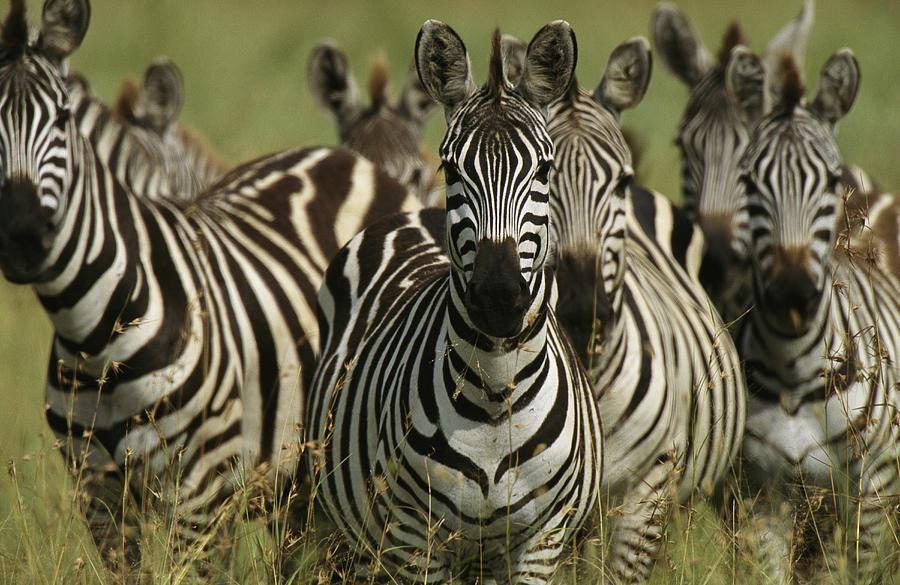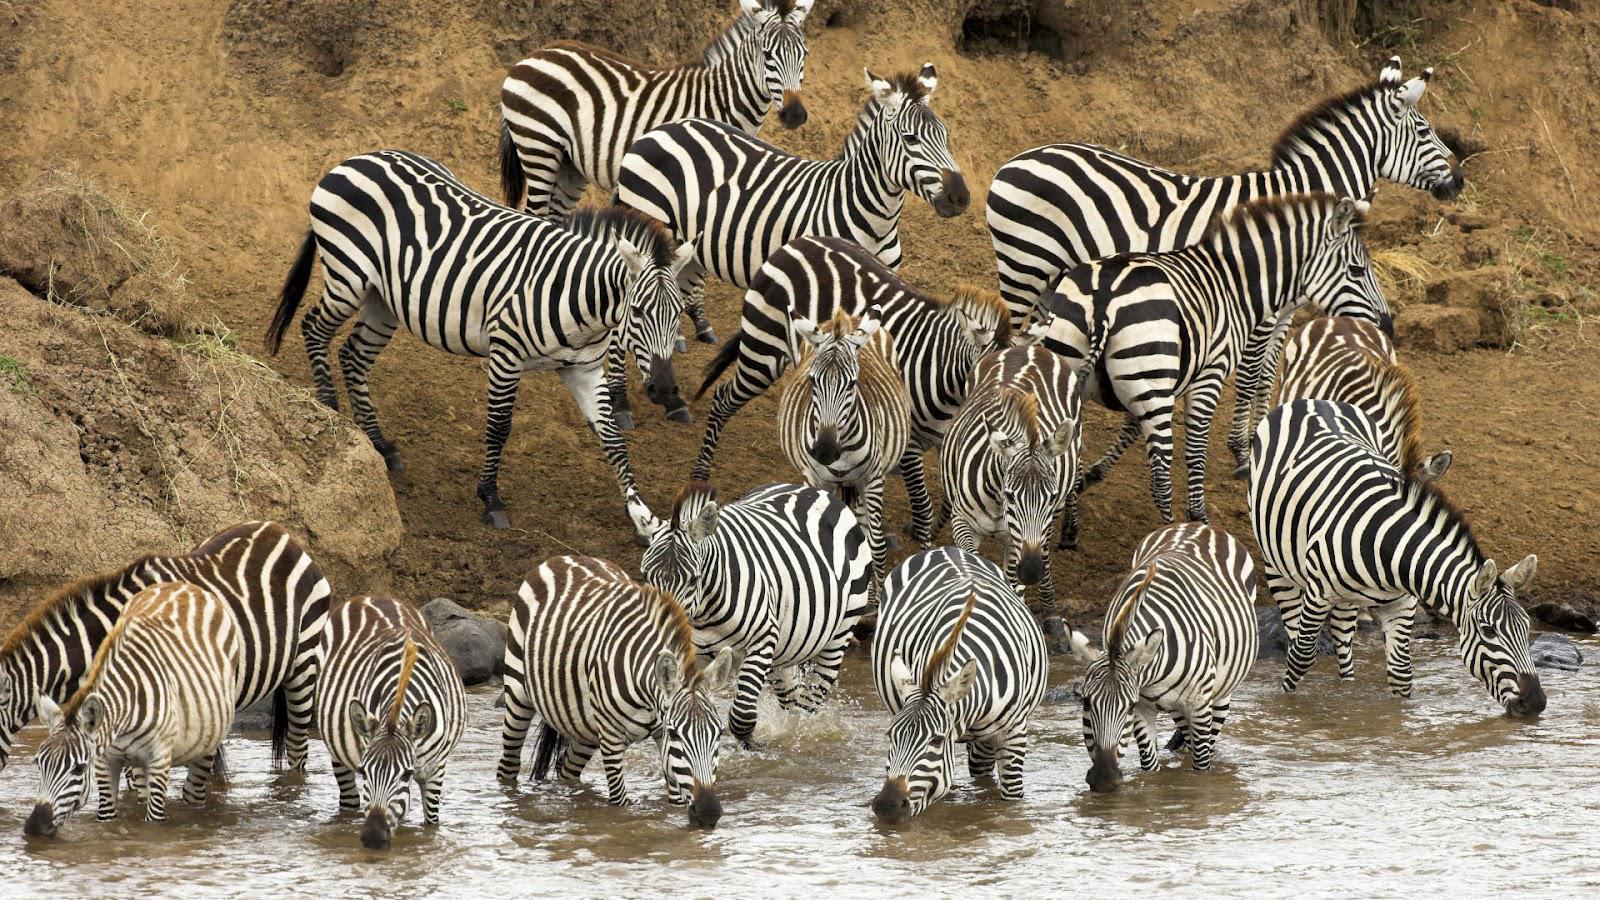The first image is the image on the left, the second image is the image on the right. Examine the images to the left and right. Is the description "Some zebras are in water." accurate? Answer yes or no. Yes. The first image is the image on the left, the second image is the image on the right. Assess this claim about the two images: "The left image shows several forward-turned zebra in the foreground, and the right image includes several zebras standing in water.". Correct or not? Answer yes or no. Yes. 